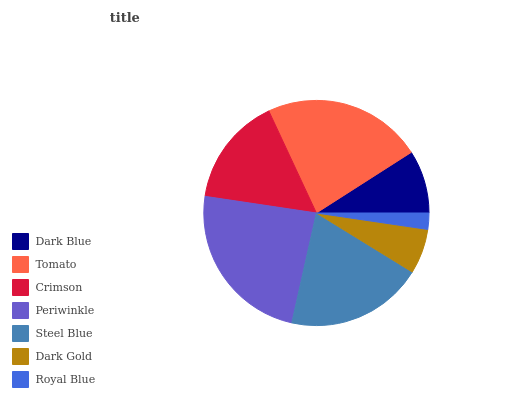Is Royal Blue the minimum?
Answer yes or no. Yes. Is Periwinkle the maximum?
Answer yes or no. Yes. Is Tomato the minimum?
Answer yes or no. No. Is Tomato the maximum?
Answer yes or no. No. Is Tomato greater than Dark Blue?
Answer yes or no. Yes. Is Dark Blue less than Tomato?
Answer yes or no. Yes. Is Dark Blue greater than Tomato?
Answer yes or no. No. Is Tomato less than Dark Blue?
Answer yes or no. No. Is Crimson the high median?
Answer yes or no. Yes. Is Crimson the low median?
Answer yes or no. Yes. Is Periwinkle the high median?
Answer yes or no. No. Is Periwinkle the low median?
Answer yes or no. No. 